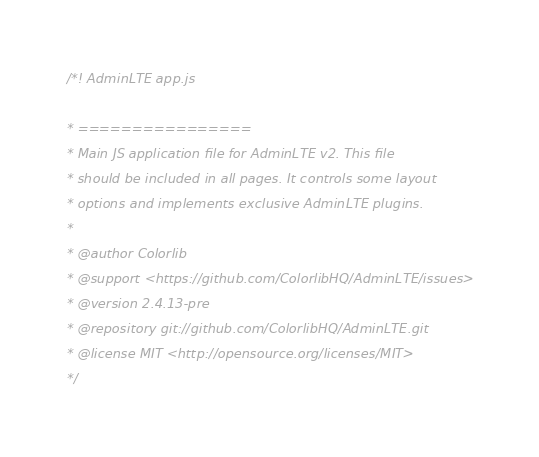Convert code to text. <code><loc_0><loc_0><loc_500><loc_500><_JavaScript_>/*! AdminLTE app.js

* ================
* Main JS application file for AdminLTE v2. This file
* should be included in all pages. It controls some layout
* options and implements exclusive AdminLTE plugins.
*
* @author Colorlib
* @support <https://github.com/ColorlibHQ/AdminLTE/issues>
* @version 2.4.13-pre
* @repository git://github.com/ColorlibHQ/AdminLTE.git
* @license MIT <http://opensource.org/licenses/MIT>
*/</code> 